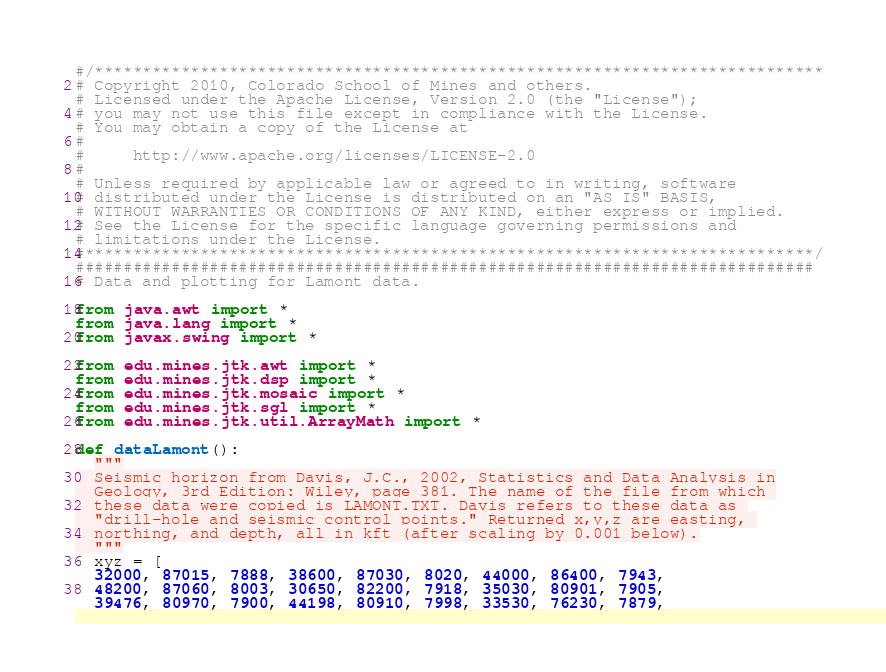<code> <loc_0><loc_0><loc_500><loc_500><_Python_>#/****************************************************************************
# Copyright 2010, Colorado School of Mines and others.
# Licensed under the Apache License, Version 2.0 (the "License");
# you may not use this file except in compliance with the License.
# You may obtain a copy of the License at
#
#     http://www.apache.org/licenses/LICENSE-2.0
#
# Unless required by applicable law or agreed to in writing, software
# distributed under the License is distributed on an "AS IS" BASIS,
# WITHOUT WARRANTIES OR CONDITIONS OF ANY KIND, either express or implied.
# See the License for the specific language governing permissions and
# limitations under the License.
#****************************************************************************/
#############################################################################
# Data and plotting for Lamont data.

from java.awt import *
from java.lang import *
from javax.swing import *

from edu.mines.jtk.awt import *
from edu.mines.jtk.dsp import *
from edu.mines.jtk.mosaic import *
from edu.mines.jtk.sgl import *
from edu.mines.jtk.util.ArrayMath import *

def dataLamont():
  """
  Seismic horizon from Davis, J.C., 2002, Statistics and Data Analysis in
  Geology, 3rd Edition: Wiley, page 381. The name of the file from which 
  these data were copied is LAMONT.TXT. Davis refers to these data as 
  "drill-hole and seismic control points." Returned x,y,z are easting, 
  northing, and depth, all in kft (after scaling by 0.001 below).
  """
  xyz = [
  32000, 87015, 7888, 38600, 87030, 8020, 44000, 86400, 7943,
  48200, 87060, 8003, 30650, 82200, 7918, 35030, 80901, 7905,
  39476, 80970, 7900, 44198, 80910, 7998, 33530, 76230, 7879,</code> 